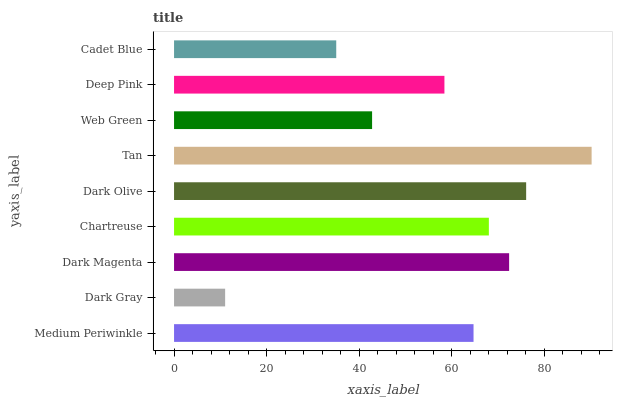Is Dark Gray the minimum?
Answer yes or no. Yes. Is Tan the maximum?
Answer yes or no. Yes. Is Dark Magenta the minimum?
Answer yes or no. No. Is Dark Magenta the maximum?
Answer yes or no. No. Is Dark Magenta greater than Dark Gray?
Answer yes or no. Yes. Is Dark Gray less than Dark Magenta?
Answer yes or no. Yes. Is Dark Gray greater than Dark Magenta?
Answer yes or no. No. Is Dark Magenta less than Dark Gray?
Answer yes or no. No. Is Medium Periwinkle the high median?
Answer yes or no. Yes. Is Medium Periwinkle the low median?
Answer yes or no. Yes. Is Dark Gray the high median?
Answer yes or no. No. Is Deep Pink the low median?
Answer yes or no. No. 